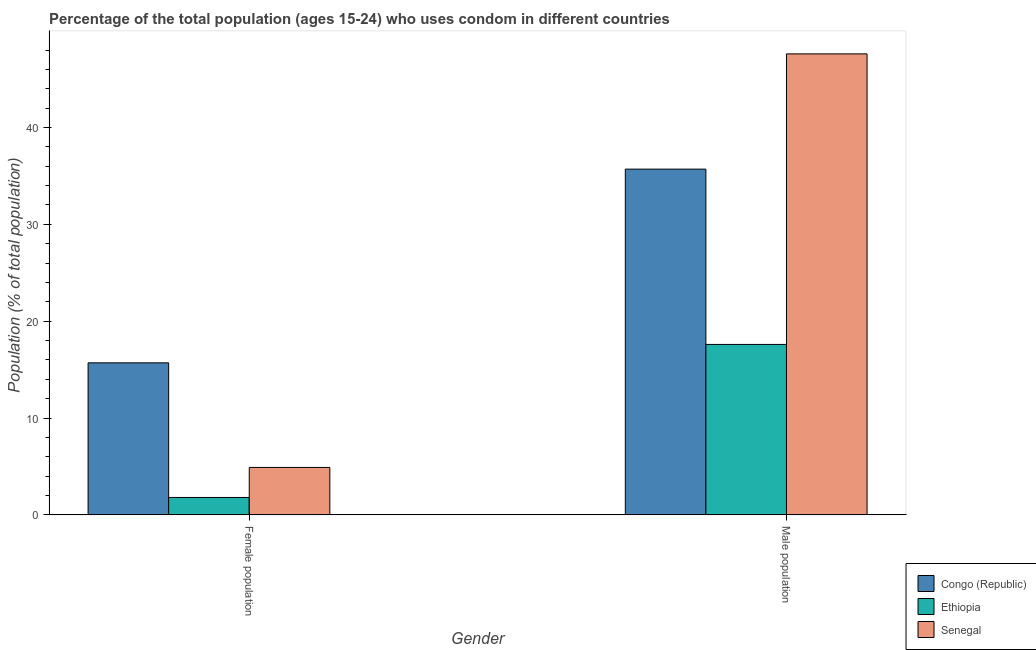Are the number of bars on each tick of the X-axis equal?
Ensure brevity in your answer.  Yes. What is the label of the 2nd group of bars from the left?
Your answer should be very brief. Male population. Across all countries, what is the maximum male population?
Provide a succinct answer. 47.6. Across all countries, what is the minimum male population?
Provide a short and direct response. 17.6. In which country was the male population maximum?
Your answer should be very brief. Senegal. In which country was the male population minimum?
Offer a very short reply. Ethiopia. What is the total male population in the graph?
Keep it short and to the point. 100.9. What is the difference between the male population in Ethiopia and that in Congo (Republic)?
Offer a very short reply. -18.1. What is the difference between the male population in Ethiopia and the female population in Senegal?
Give a very brief answer. 12.7. What is the average male population per country?
Your answer should be very brief. 33.63. What is the difference between the male population and female population in Senegal?
Give a very brief answer. 42.7. What is the ratio of the female population in Congo (Republic) to that in Senegal?
Your response must be concise. 3.2. What does the 1st bar from the left in Female population represents?
Ensure brevity in your answer.  Congo (Republic). What does the 3rd bar from the right in Female population represents?
Your answer should be compact. Congo (Republic). How many countries are there in the graph?
Your answer should be compact. 3. Are the values on the major ticks of Y-axis written in scientific E-notation?
Offer a terse response. No. Does the graph contain any zero values?
Your answer should be compact. No. How many legend labels are there?
Your answer should be compact. 3. What is the title of the graph?
Keep it short and to the point. Percentage of the total population (ages 15-24) who uses condom in different countries. Does "Sub-Saharan Africa (all income levels)" appear as one of the legend labels in the graph?
Offer a very short reply. No. What is the label or title of the Y-axis?
Offer a terse response. Population (% of total population) . What is the Population (% of total population)  in Senegal in Female population?
Give a very brief answer. 4.9. What is the Population (% of total population)  in Congo (Republic) in Male population?
Offer a terse response. 35.7. What is the Population (% of total population)  in Ethiopia in Male population?
Your response must be concise. 17.6. What is the Population (% of total population)  in Senegal in Male population?
Keep it short and to the point. 47.6. Across all Gender, what is the maximum Population (% of total population)  in Congo (Republic)?
Make the answer very short. 35.7. Across all Gender, what is the maximum Population (% of total population)  in Senegal?
Ensure brevity in your answer.  47.6. Across all Gender, what is the minimum Population (% of total population)  of Congo (Republic)?
Your response must be concise. 15.7. Across all Gender, what is the minimum Population (% of total population)  of Senegal?
Your response must be concise. 4.9. What is the total Population (% of total population)  of Congo (Republic) in the graph?
Give a very brief answer. 51.4. What is the total Population (% of total population)  of Ethiopia in the graph?
Give a very brief answer. 19.4. What is the total Population (% of total population)  of Senegal in the graph?
Make the answer very short. 52.5. What is the difference between the Population (% of total population)  in Congo (Republic) in Female population and that in Male population?
Keep it short and to the point. -20. What is the difference between the Population (% of total population)  of Ethiopia in Female population and that in Male population?
Ensure brevity in your answer.  -15.8. What is the difference between the Population (% of total population)  of Senegal in Female population and that in Male population?
Your answer should be compact. -42.7. What is the difference between the Population (% of total population)  in Congo (Republic) in Female population and the Population (% of total population)  in Senegal in Male population?
Give a very brief answer. -31.9. What is the difference between the Population (% of total population)  in Ethiopia in Female population and the Population (% of total population)  in Senegal in Male population?
Provide a succinct answer. -45.8. What is the average Population (% of total population)  in Congo (Republic) per Gender?
Give a very brief answer. 25.7. What is the average Population (% of total population)  of Ethiopia per Gender?
Your response must be concise. 9.7. What is the average Population (% of total population)  of Senegal per Gender?
Offer a very short reply. 26.25. What is the difference between the Population (% of total population)  in Congo (Republic) and Population (% of total population)  in Ethiopia in Female population?
Your answer should be compact. 13.9. What is the difference between the Population (% of total population)  of Congo (Republic) and Population (% of total population)  of Ethiopia in Male population?
Provide a short and direct response. 18.1. What is the ratio of the Population (% of total population)  in Congo (Republic) in Female population to that in Male population?
Your answer should be very brief. 0.44. What is the ratio of the Population (% of total population)  of Ethiopia in Female population to that in Male population?
Your answer should be very brief. 0.1. What is the ratio of the Population (% of total population)  of Senegal in Female population to that in Male population?
Provide a succinct answer. 0.1. What is the difference between the highest and the second highest Population (% of total population)  of Senegal?
Provide a succinct answer. 42.7. What is the difference between the highest and the lowest Population (% of total population)  in Congo (Republic)?
Make the answer very short. 20. What is the difference between the highest and the lowest Population (% of total population)  in Ethiopia?
Make the answer very short. 15.8. What is the difference between the highest and the lowest Population (% of total population)  in Senegal?
Ensure brevity in your answer.  42.7. 